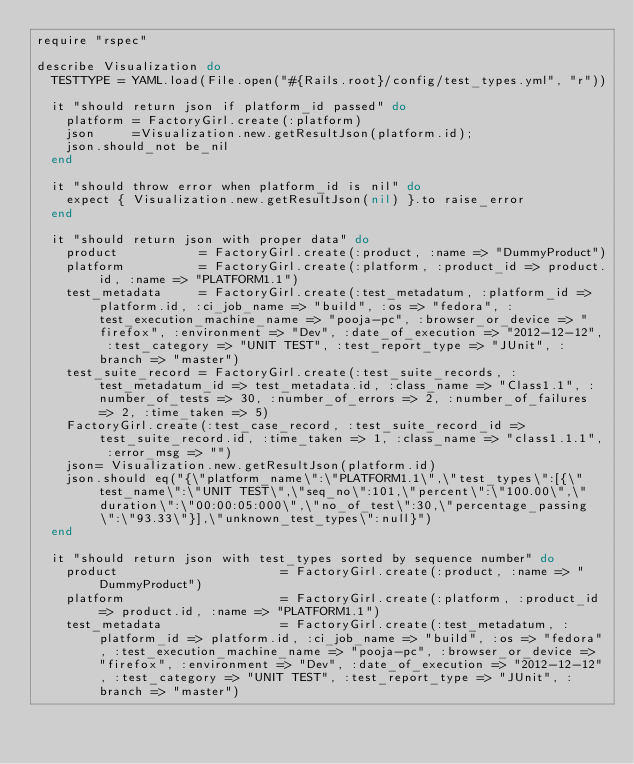Convert code to text. <code><loc_0><loc_0><loc_500><loc_500><_Ruby_>require "rspec"

describe Visualization do
  TESTTYPE = YAML.load(File.open("#{Rails.root}/config/test_types.yml", "r"))

  it "should return json if platform_id passed" do
    platform = FactoryGirl.create(:platform)
    json     =Visualization.new.getResultJson(platform.id);
    json.should_not be_nil
  end

  it "should throw error when platform_id is nil" do
    expect { Visualization.new.getResultJson(nil) }.to raise_error
  end

  it "should return json with proper data" do
    product           = FactoryGirl.create(:product, :name => "DummyProduct")
    platform          = FactoryGirl.create(:platform, :product_id => product.id, :name => "PLATFORM1.1")
    test_metadata     = FactoryGirl.create(:test_metadatum, :platform_id => platform.id, :ci_job_name => "build", :os => "fedora", :test_execution_machine_name => "pooja-pc", :browser_or_device => "firefox", :environment => "Dev", :date_of_execution => "2012-12-12", :test_category => "UNIT TEST", :test_report_type => "JUnit", :branch => "master")
    test_suite_record = FactoryGirl.create(:test_suite_records, :test_metadatum_id => test_metadata.id, :class_name => "Class1.1", :number_of_tests => 30, :number_of_errors => 2, :number_of_failures => 2, :time_taken => 5)
    FactoryGirl.create(:test_case_record, :test_suite_record_id => test_suite_record.id, :time_taken => 1, :class_name => "class1.1.1", :error_msg => "")
    json= Visualization.new.getResultJson(platform.id)
    json.should eq("{\"platform_name\":\"PLATFORM1.1\",\"test_types\":[{\"test_name\":\"UNIT TEST\",\"seq_no\":101,\"percent\":\"100.00\",\"duration\":\"00:00:05:000\",\"no_of_test\":30,\"percentage_passing\":\"93.33\"}],\"unknown_test_types\":null}")
  end

  it "should return json with test_types sorted by sequence number" do
    product                      = FactoryGirl.create(:product, :name => "DummyProduct")
    platform                     = FactoryGirl.create(:platform, :product_id => product.id, :name => "PLATFORM1.1")
    test_metadata                = FactoryGirl.create(:test_metadatum, :platform_id => platform.id, :ci_job_name => "build", :os => "fedora", :test_execution_machine_name => "pooja-pc", :browser_or_device => "firefox", :environment => "Dev", :date_of_execution => "2012-12-12", :test_category => "UNIT TEST", :test_report_type => "JUnit", :branch => "master")</code> 